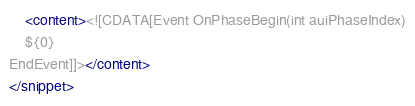<code> <loc_0><loc_0><loc_500><loc_500><_XML_>    <content><![CDATA[Event OnPhaseBegin(int auiPhaseIndex)
    ${0}
EndEvent]]></content>
</snippet>
</code> 